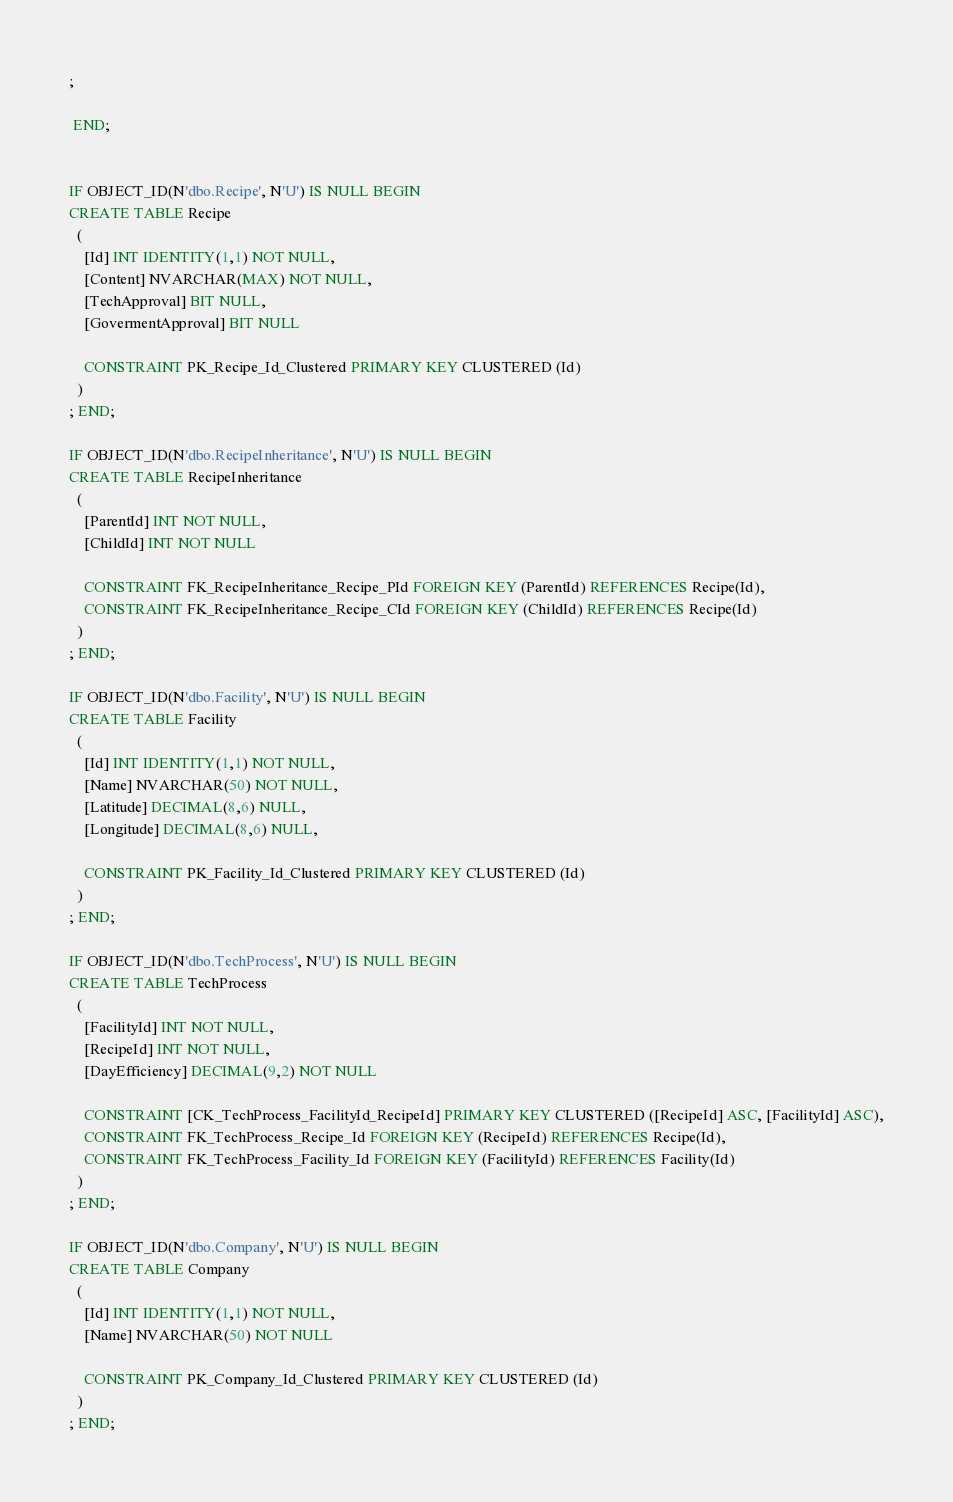Convert code to text. <code><loc_0><loc_0><loc_500><loc_500><_SQL_>;

 END;


IF OBJECT_ID(N'dbo.Recipe', N'U') IS NULL BEGIN 
CREATE TABLE Recipe
  (
  	[Id] INT IDENTITY(1,1) NOT NULL, 
  	[Content] NVARCHAR(MAX) NOT NULL,
  	[TechApproval] BIT NULL,
  	[GovermentApproval] BIT NULL

  	CONSTRAINT PK_Recipe_Id_Clustered PRIMARY KEY CLUSTERED (Id)
  )
; END;

IF OBJECT_ID(N'dbo.RecipeInheritance', N'U') IS NULL BEGIN 
CREATE TABLE RecipeInheritance
  (
  	[ParentId] INT NOT NULL, 
  	[ChildId] INT NOT NULL

  	CONSTRAINT FK_RecipeInheritance_Recipe_PId FOREIGN KEY (ParentId) REFERENCES Recipe(Id),
  	CONSTRAINT FK_RecipeInheritance_Recipe_CId FOREIGN KEY (ChildId) REFERENCES Recipe(Id)
  )
; END;

IF OBJECT_ID(N'dbo.Facility', N'U') IS NULL BEGIN 
CREATE TABLE Facility
  (
  	[Id] INT IDENTITY(1,1) NOT NULL, 
  	[Name] NVARCHAR(50) NOT NULL,
  	[Latitude] DECIMAL(8,6) NULL,
  	[Longitude] DECIMAL(8,6) NULL,

  	CONSTRAINT PK_Facility_Id_Clustered PRIMARY KEY CLUSTERED (Id)
  )
; END;

IF OBJECT_ID(N'dbo.TechProcess', N'U') IS NULL BEGIN 
CREATE TABLE TechProcess
  (
  	[FacilityId] INT NOT NULL,
  	[RecipeId] INT NOT NULL,   	
  	[DayEfficiency] DECIMAL(9,2) NOT NULL

  	CONSTRAINT [CK_TechProcess_FacilityId_RecipeId] PRIMARY KEY CLUSTERED ([RecipeId] ASC, [FacilityId] ASC),
  	CONSTRAINT FK_TechProcess_Recipe_Id FOREIGN KEY (RecipeId) REFERENCES Recipe(Id),
  	CONSTRAINT FK_TechProcess_Facility_Id FOREIGN KEY (FacilityId) REFERENCES Facility(Id)
  )
; END;

IF OBJECT_ID(N'dbo.Company', N'U') IS NULL BEGIN 
CREATE TABLE Company
  (
  	[Id] INT IDENTITY(1,1) NOT NULL, 
  	[Name] NVARCHAR(50) NOT NULL

  	CONSTRAINT PK_Company_Id_Clustered PRIMARY KEY CLUSTERED (Id)
  )
; END;
</code> 